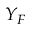<formula> <loc_0><loc_0><loc_500><loc_500>Y _ { F }</formula> 